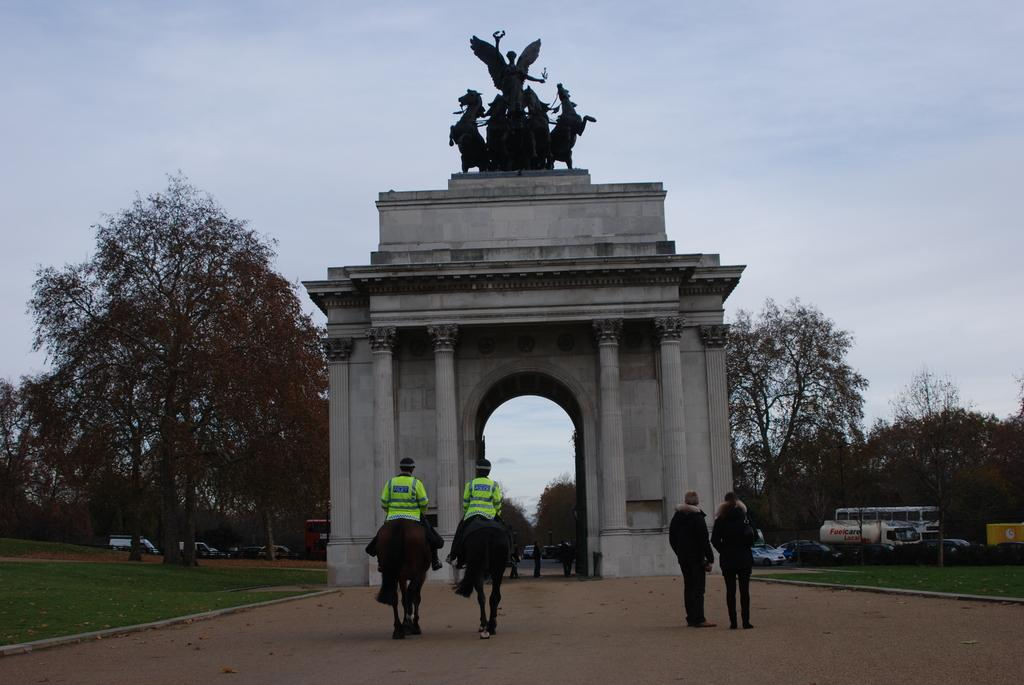How many people are in the group visible in the image? There is a group of people in the image, but the exact number cannot be determined from the provided facts. What types of vehicles are on the ground in the image? The provided facts do not specify the types of vehicles present in the image. What are the pillars supporting in the image? The provided facts do not specify what the pillars are supporting in the image. What is the wall made of in the image? The provided facts do not specify the material of the wall in the image. What is the statue depicting in the image? The provided facts do not specify what the statue is depicting in the image. How many trees are in the image? The provided facts do not specify the number of trees present in the image. What is visible in the background of the image? The sky is visible in the background of the image. Can you see a rabbit wearing a cap in the image? There is no rabbit or cap present in the image. Are the people in the image sleeping? The provided facts do not indicate whether the people in the image are sleeping or not. 